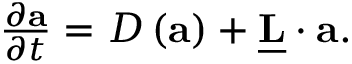<formula> <loc_0><loc_0><loc_500><loc_500>\begin{array} { r } { \frac { \partial a } { \partial t } = D \left ( a \right ) + \underline { L } \cdot a . } \end{array}</formula> 